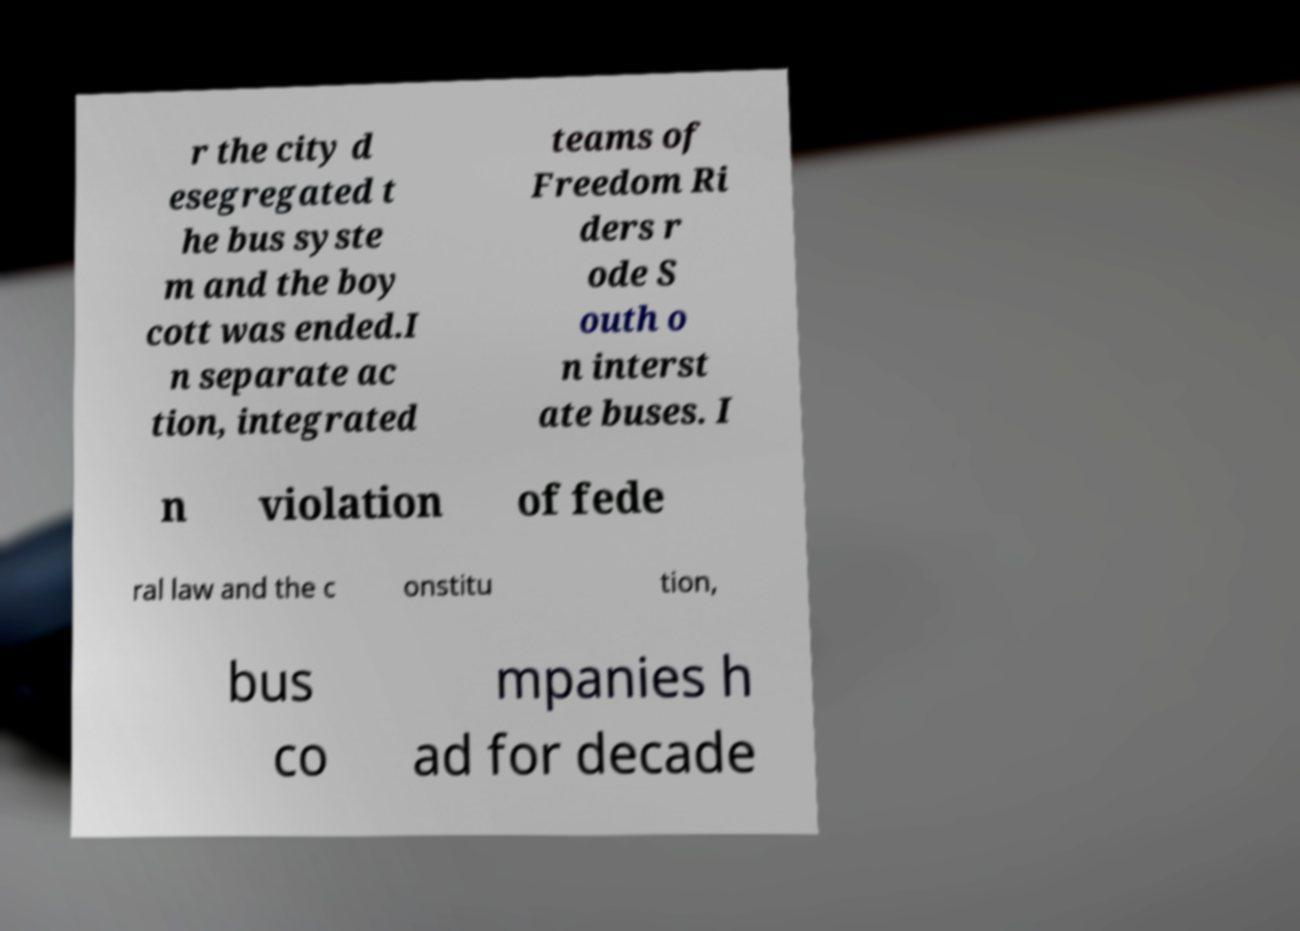There's text embedded in this image that I need extracted. Can you transcribe it verbatim? r the city d esegregated t he bus syste m and the boy cott was ended.I n separate ac tion, integrated teams of Freedom Ri ders r ode S outh o n interst ate buses. I n violation of fede ral law and the c onstitu tion, bus co mpanies h ad for decade 